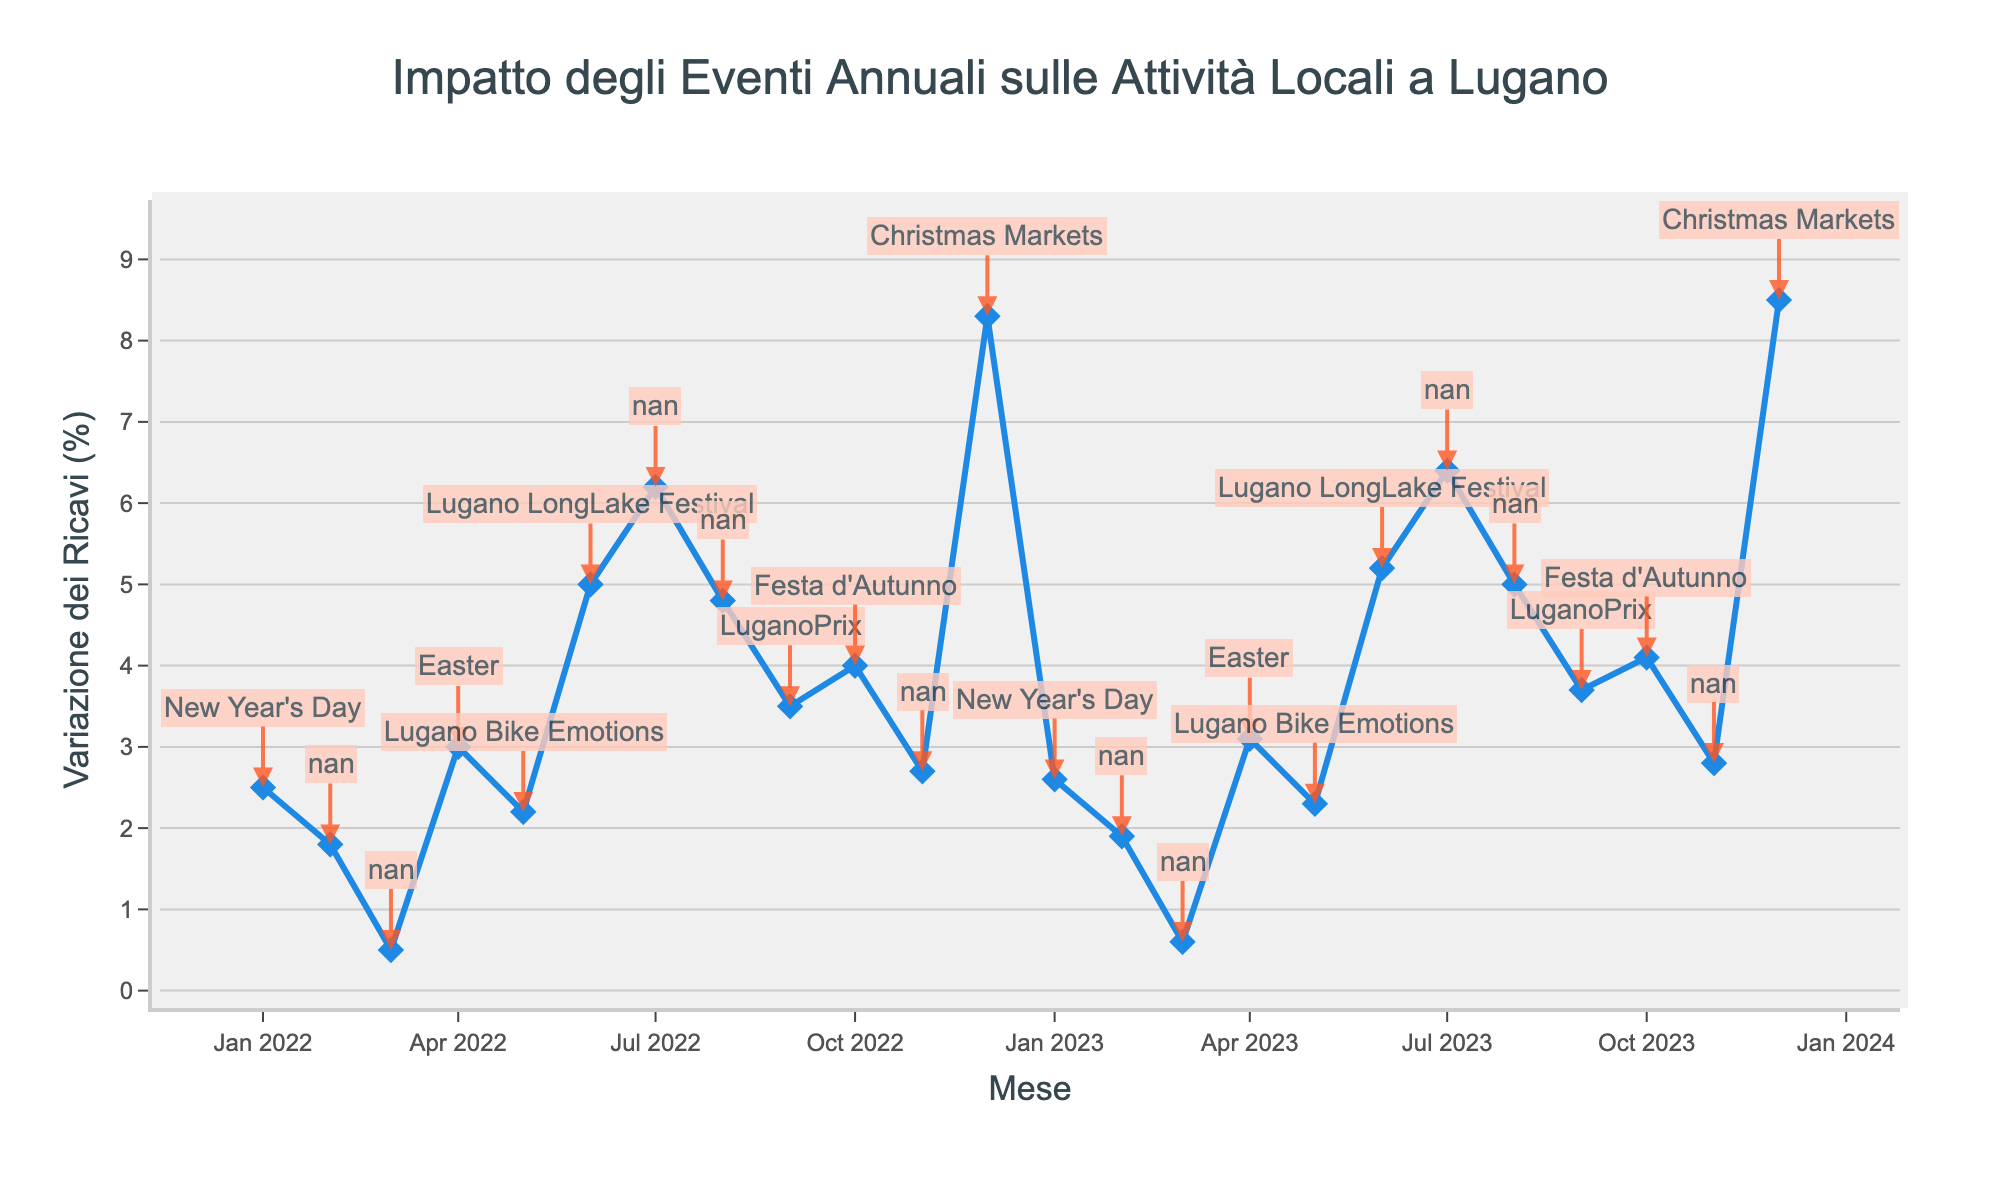What's the title of the figure? The title is located at the top of the figure, which provides an overview of the chart's content.
Answer: Impatto degli Eventi Annuali sulle Attività Locali a Lugano What does the x-axis represent? The x-axis is labeled "Mese," which translates to "Month" in English, indicating the months over the period displayed.
Answer: Mese (Month) What does the y-axis represent? The y-axis label is "Variazione dei Ricavi (%)", which translates to "Revenue Change (%)". It shows the percentage change in revenue for each month.
Answer: Variazione dei Ricavi (%) Which month has the highest revenue change? By looking at the y-axis values, the highest revenue change can be identified as December, with a peak value of 8.5%.
Answer: December How does revenue change in July 2022 compare to July 2023? Look at the revenue change percentage for both July 2022 and July 2023. July 2022 is 6.2% and July 2023 is 6.4%.
Answer: July 2023 is 0.2% higher than July 2022 What is the average revenue change for the month of June over the two years? Calculate the average by adding the revenue changes for June 2022 (5.0%) and June 2023 (5.2%) and dividing by 2. (5.0 + 5.2) / 2 = 5.1
Answer: 5.1% By how much did the revenue change increase from November 2022 to December 2022? Subtract the revenue change in November 2022 (2.7%) from December 2022 (8.3%). 8.3% - 2.7% = 5.6%
Answer: 5.6% Identify one event or festival that occurs in February and its impact on revenue change in 2023. February features the Carnival of Lugano, and the revenue change in February 2023 is 1.9%.
Answer: Carnival of Lugano, 1.9% Which event corresponds to the largest single-month increase in revenue change over the two-year period? Observe the annotations and find the event with the highest revenue change. The largest increase is with the Christmas Markets in December 2023 with 8.5%.
Answer: Christmas Markets How does the revenue change in January 2022 compare to January 2023? Check the revenue change for January in both years: January 2022 is 2.5%, and January 2023 is 2.6%.
Answer: January 2023 is 0.1% higher than January 2022 